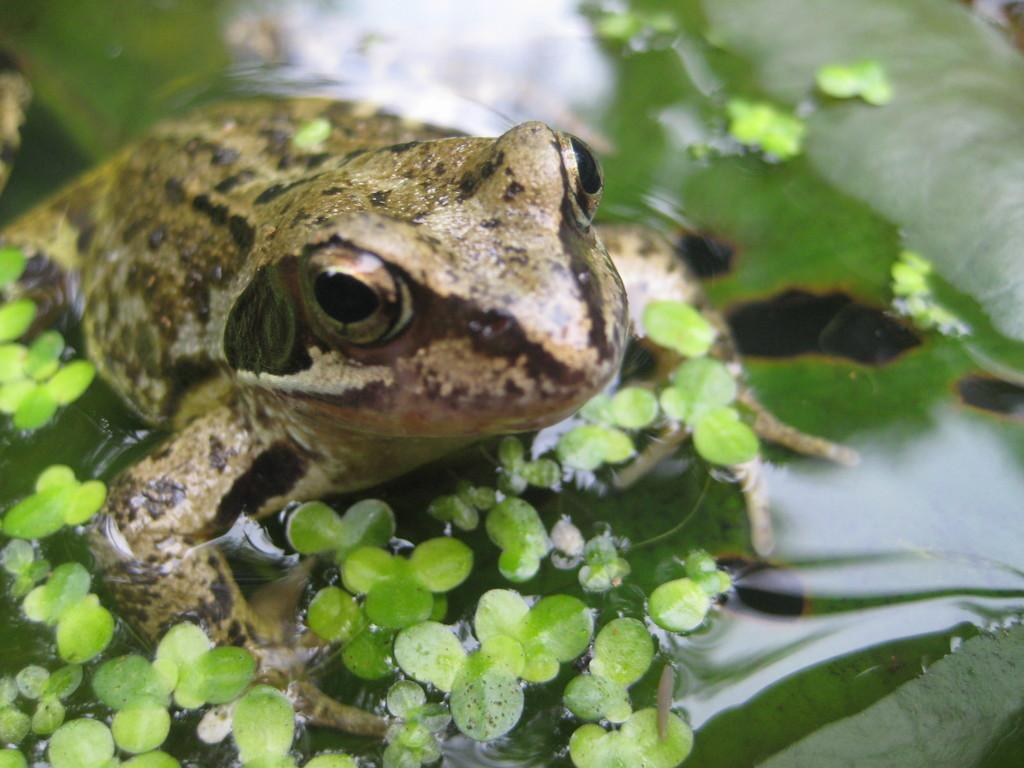What is the primary element in the image? There is water in the image. What type of animal can be seen in the water? There is a frog in the water. What can be observed floating on the water? Green color leaves are present on the water. What type of cover is protecting the frog from the sun in the image? There is no cover present in the image to protect the frog from the sun. 